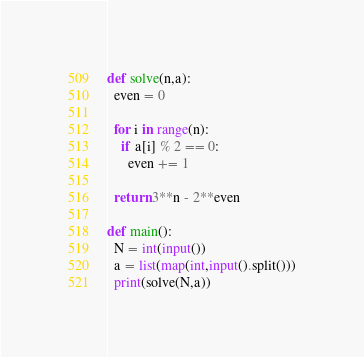Convert code to text. <code><loc_0><loc_0><loc_500><loc_500><_Python_>def solve(n,a):
  even = 0
  
  for i in range(n):
    if a[i] % 2 == 0:
      even += 1
  
  return 3**n - 2**even
  
def main():
  N = int(input())
  a = list(map(int,input().split()))
  print(solve(N,a))
</code> 